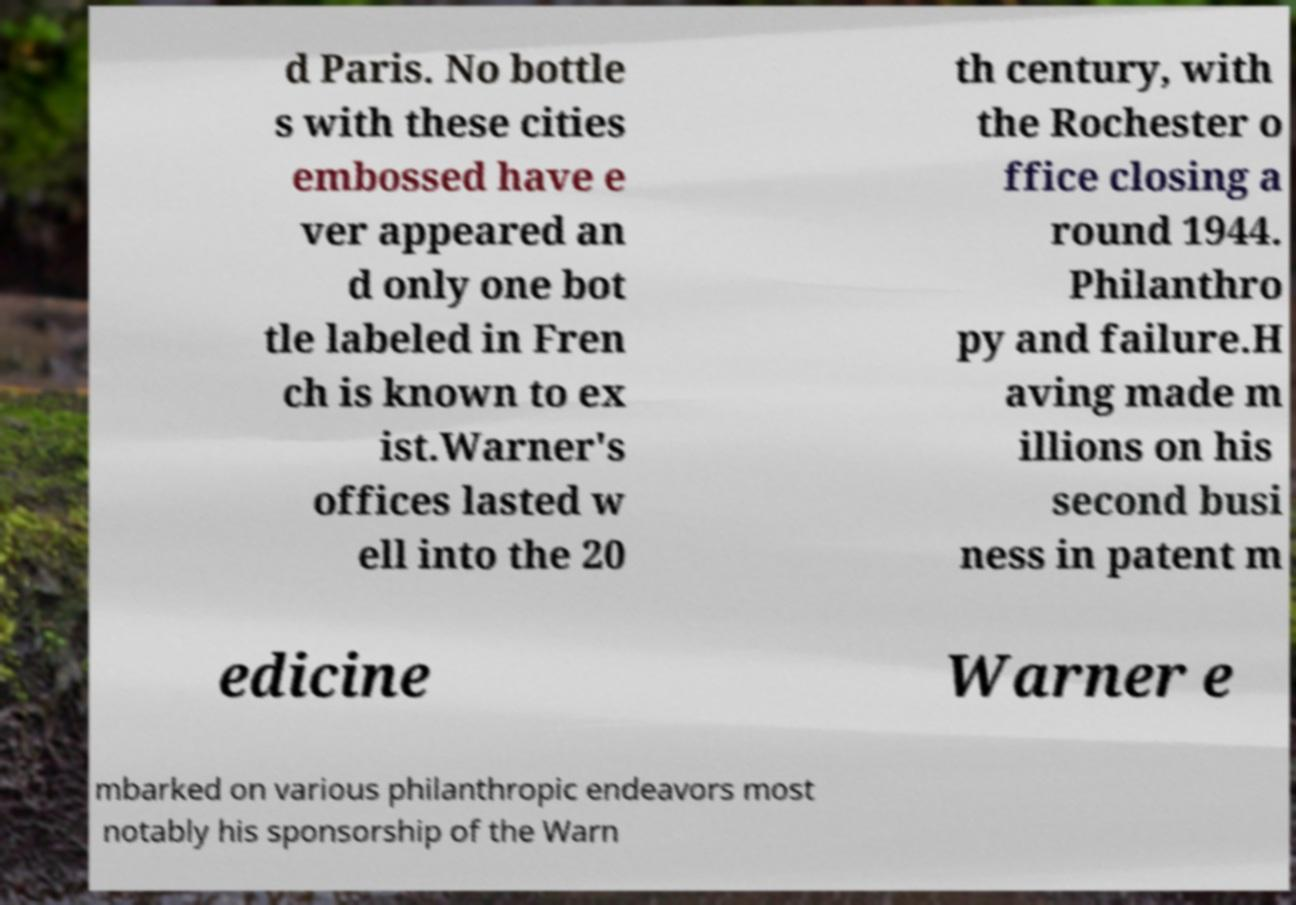Please read and relay the text visible in this image. What does it say? d Paris. No bottle s with these cities embossed have e ver appeared an d only one bot tle labeled in Fren ch is known to ex ist.Warner's offices lasted w ell into the 20 th century, with the Rochester o ffice closing a round 1944. Philanthro py and failure.H aving made m illions on his second busi ness in patent m edicine Warner e mbarked on various philanthropic endeavors most notably his sponsorship of the Warn 